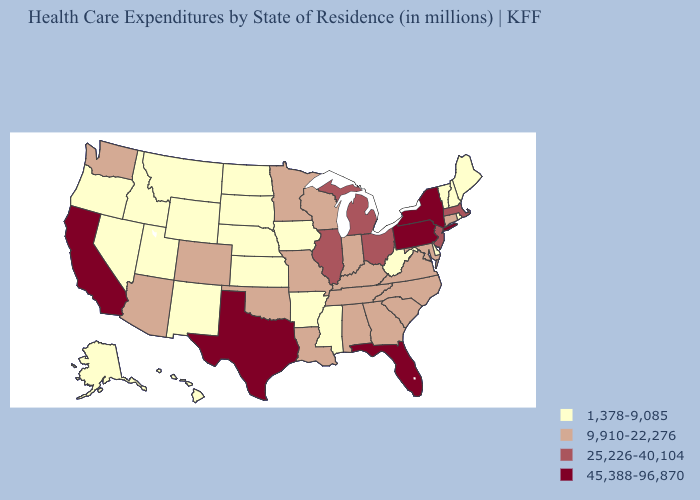Does Rhode Island have the highest value in the USA?
Give a very brief answer. No. Which states have the lowest value in the MidWest?
Give a very brief answer. Iowa, Kansas, Nebraska, North Dakota, South Dakota. What is the highest value in the West ?
Give a very brief answer. 45,388-96,870. Name the states that have a value in the range 45,388-96,870?
Quick response, please. California, Florida, New York, Pennsylvania, Texas. Does New York have the highest value in the USA?
Quick response, please. Yes. What is the highest value in states that border Minnesota?
Keep it brief. 9,910-22,276. What is the value of Kentucky?
Give a very brief answer. 9,910-22,276. Does the map have missing data?
Concise answer only. No. Which states have the highest value in the USA?
Give a very brief answer. California, Florida, New York, Pennsylvania, Texas. Name the states that have a value in the range 25,226-40,104?
Be succinct. Illinois, Massachusetts, Michigan, New Jersey, Ohio. Does Texas have the lowest value in the USA?
Write a very short answer. No. What is the highest value in the USA?
Quick response, please. 45,388-96,870. What is the value of Arkansas?
Short answer required. 1,378-9,085. Name the states that have a value in the range 1,378-9,085?
Be succinct. Alaska, Arkansas, Delaware, Hawaii, Idaho, Iowa, Kansas, Maine, Mississippi, Montana, Nebraska, Nevada, New Hampshire, New Mexico, North Dakota, Oregon, Rhode Island, South Dakota, Utah, Vermont, West Virginia, Wyoming. Among the states that border Virginia , which have the highest value?
Be succinct. Kentucky, Maryland, North Carolina, Tennessee. 